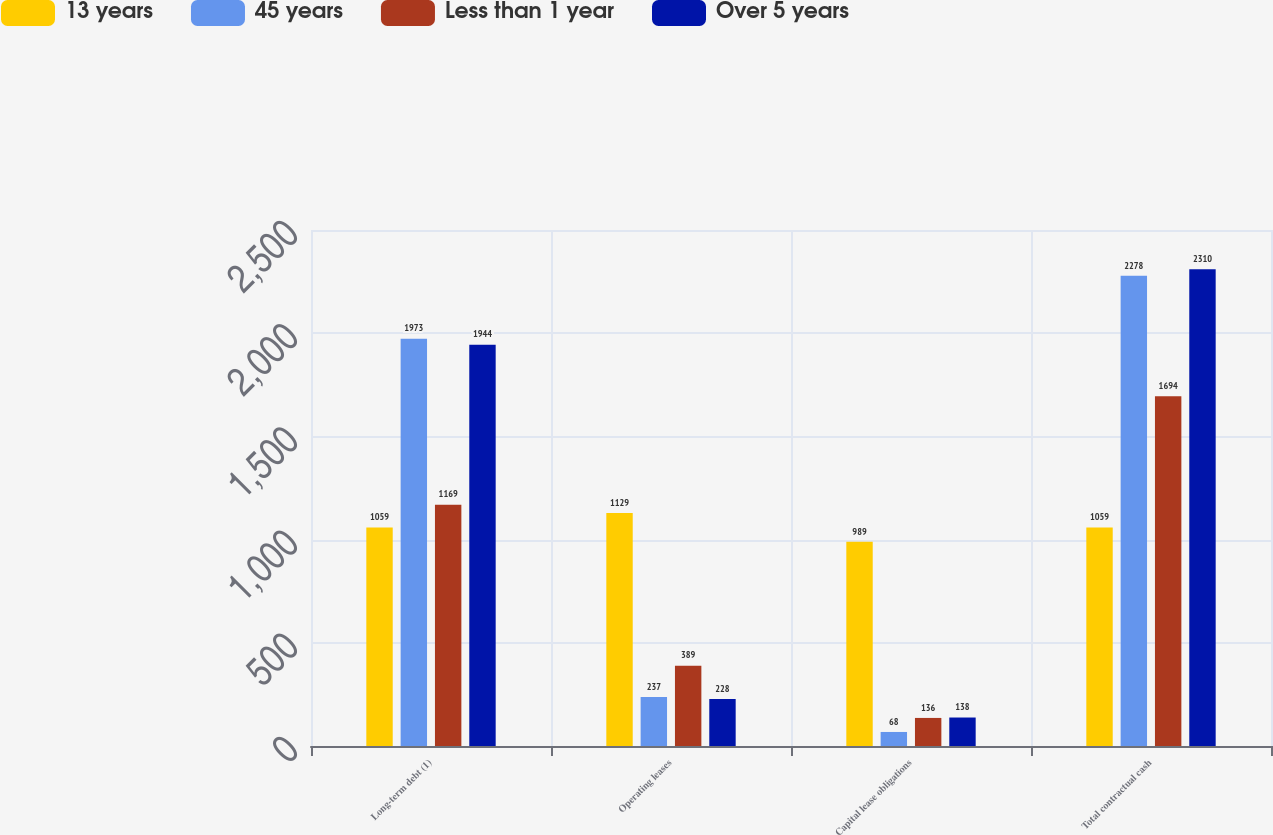<chart> <loc_0><loc_0><loc_500><loc_500><stacked_bar_chart><ecel><fcel>Long-term debt (1)<fcel>Operating leases<fcel>Capital lease obligations<fcel>Total contractual cash<nl><fcel>13 years<fcel>1059<fcel>1129<fcel>989<fcel>1059<nl><fcel>45 years<fcel>1973<fcel>237<fcel>68<fcel>2278<nl><fcel>Less than 1 year<fcel>1169<fcel>389<fcel>136<fcel>1694<nl><fcel>Over 5 years<fcel>1944<fcel>228<fcel>138<fcel>2310<nl></chart> 